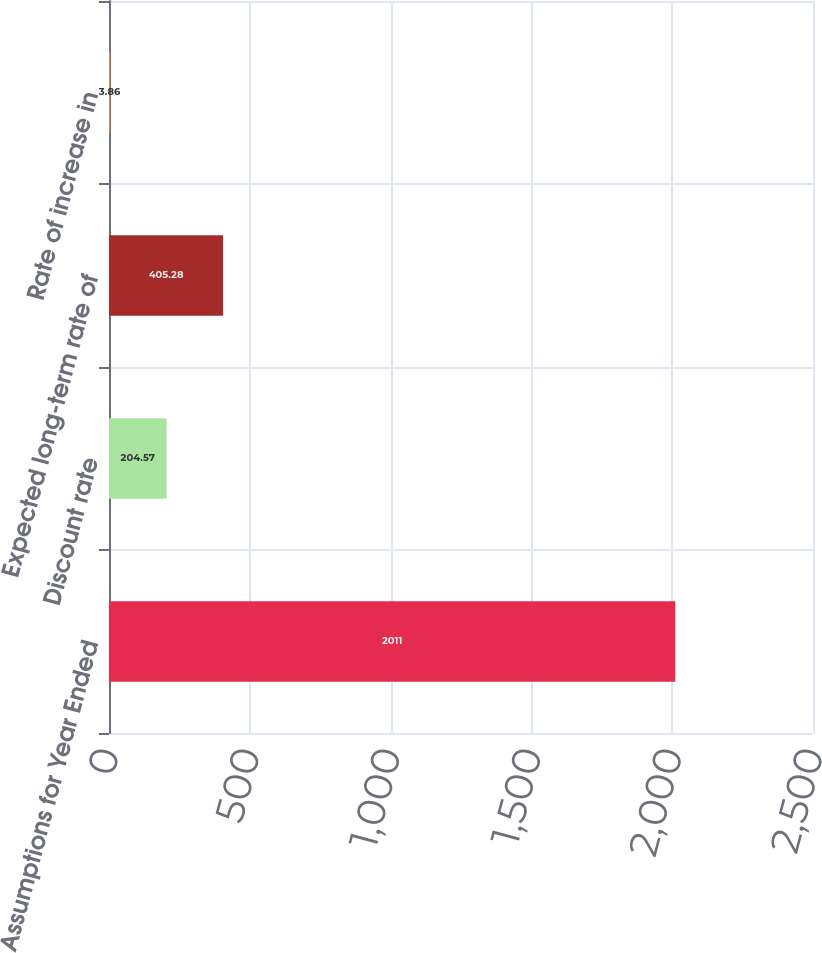Convert chart. <chart><loc_0><loc_0><loc_500><loc_500><bar_chart><fcel>Assumptions for Year Ended<fcel>Discount rate<fcel>Expected long-term rate of<fcel>Rate of increase in<nl><fcel>2011<fcel>204.57<fcel>405.28<fcel>3.86<nl></chart> 